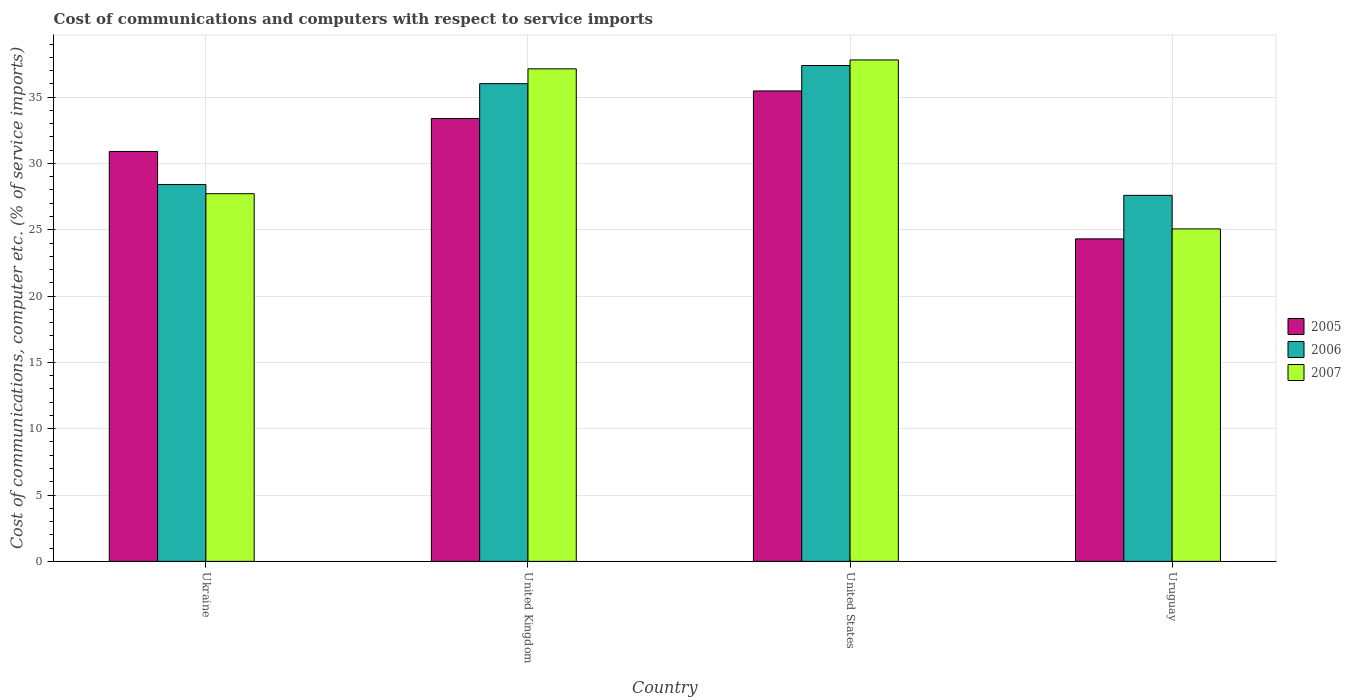How many groups of bars are there?
Ensure brevity in your answer.  4. Are the number of bars on each tick of the X-axis equal?
Provide a short and direct response. Yes. How many bars are there on the 1st tick from the right?
Provide a succinct answer. 3. What is the label of the 4th group of bars from the left?
Provide a succinct answer. Uruguay. In how many cases, is the number of bars for a given country not equal to the number of legend labels?
Offer a very short reply. 0. What is the cost of communications and computers in 2005 in Ukraine?
Give a very brief answer. 30.9. Across all countries, what is the maximum cost of communications and computers in 2006?
Provide a succinct answer. 37.38. Across all countries, what is the minimum cost of communications and computers in 2005?
Provide a short and direct response. 24.32. In which country was the cost of communications and computers in 2007 minimum?
Ensure brevity in your answer.  Uruguay. What is the total cost of communications and computers in 2006 in the graph?
Make the answer very short. 129.4. What is the difference between the cost of communications and computers in 2005 in Ukraine and that in United Kingdom?
Your answer should be compact. -2.49. What is the difference between the cost of communications and computers in 2006 in Ukraine and the cost of communications and computers in 2007 in Uruguay?
Offer a very short reply. 3.34. What is the average cost of communications and computers in 2007 per country?
Provide a short and direct response. 31.93. What is the difference between the cost of communications and computers of/in 2006 and cost of communications and computers of/in 2005 in Uruguay?
Provide a succinct answer. 3.28. In how many countries, is the cost of communications and computers in 2006 greater than 19 %?
Keep it short and to the point. 4. What is the ratio of the cost of communications and computers in 2007 in United Kingdom to that in Uruguay?
Offer a terse response. 1.48. Is the cost of communications and computers in 2005 in Ukraine less than that in Uruguay?
Make the answer very short. No. Is the difference between the cost of communications and computers in 2006 in Ukraine and Uruguay greater than the difference between the cost of communications and computers in 2005 in Ukraine and Uruguay?
Offer a very short reply. No. What is the difference between the highest and the second highest cost of communications and computers in 2006?
Your answer should be very brief. -7.61. What is the difference between the highest and the lowest cost of communications and computers in 2005?
Provide a succinct answer. 11.15. In how many countries, is the cost of communications and computers in 2006 greater than the average cost of communications and computers in 2006 taken over all countries?
Offer a very short reply. 2. What does the 3rd bar from the left in Uruguay represents?
Make the answer very short. 2007. Is it the case that in every country, the sum of the cost of communications and computers in 2005 and cost of communications and computers in 2006 is greater than the cost of communications and computers in 2007?
Ensure brevity in your answer.  Yes. Are all the bars in the graph horizontal?
Make the answer very short. No. What is the difference between two consecutive major ticks on the Y-axis?
Your answer should be very brief. 5. Where does the legend appear in the graph?
Provide a short and direct response. Center right. How many legend labels are there?
Give a very brief answer. 3. How are the legend labels stacked?
Provide a succinct answer. Vertical. What is the title of the graph?
Ensure brevity in your answer.  Cost of communications and computers with respect to service imports. What is the label or title of the Y-axis?
Give a very brief answer. Cost of communications, computer etc. (% of service imports). What is the Cost of communications, computer etc. (% of service imports) in 2005 in Ukraine?
Offer a very short reply. 30.9. What is the Cost of communications, computer etc. (% of service imports) in 2006 in Ukraine?
Your answer should be very brief. 28.41. What is the Cost of communications, computer etc. (% of service imports) in 2007 in Ukraine?
Ensure brevity in your answer.  27.72. What is the Cost of communications, computer etc. (% of service imports) of 2005 in United Kingdom?
Provide a short and direct response. 33.39. What is the Cost of communications, computer etc. (% of service imports) in 2006 in United Kingdom?
Make the answer very short. 36.02. What is the Cost of communications, computer etc. (% of service imports) of 2007 in United Kingdom?
Your response must be concise. 37.13. What is the Cost of communications, computer etc. (% of service imports) of 2005 in United States?
Offer a terse response. 35.47. What is the Cost of communications, computer etc. (% of service imports) in 2006 in United States?
Provide a succinct answer. 37.38. What is the Cost of communications, computer etc. (% of service imports) in 2007 in United States?
Keep it short and to the point. 37.8. What is the Cost of communications, computer etc. (% of service imports) of 2005 in Uruguay?
Provide a succinct answer. 24.32. What is the Cost of communications, computer etc. (% of service imports) in 2006 in Uruguay?
Your answer should be compact. 27.6. What is the Cost of communications, computer etc. (% of service imports) in 2007 in Uruguay?
Your response must be concise. 25.07. Across all countries, what is the maximum Cost of communications, computer etc. (% of service imports) of 2005?
Your response must be concise. 35.47. Across all countries, what is the maximum Cost of communications, computer etc. (% of service imports) of 2006?
Your answer should be very brief. 37.38. Across all countries, what is the maximum Cost of communications, computer etc. (% of service imports) in 2007?
Give a very brief answer. 37.8. Across all countries, what is the minimum Cost of communications, computer etc. (% of service imports) of 2005?
Your answer should be compact. 24.32. Across all countries, what is the minimum Cost of communications, computer etc. (% of service imports) of 2006?
Provide a succinct answer. 27.6. Across all countries, what is the minimum Cost of communications, computer etc. (% of service imports) of 2007?
Your answer should be very brief. 25.07. What is the total Cost of communications, computer etc. (% of service imports) in 2005 in the graph?
Your response must be concise. 124.08. What is the total Cost of communications, computer etc. (% of service imports) in 2006 in the graph?
Your answer should be compact. 129.4. What is the total Cost of communications, computer etc. (% of service imports) of 2007 in the graph?
Provide a succinct answer. 127.72. What is the difference between the Cost of communications, computer etc. (% of service imports) of 2005 in Ukraine and that in United Kingdom?
Ensure brevity in your answer.  -2.49. What is the difference between the Cost of communications, computer etc. (% of service imports) in 2006 in Ukraine and that in United Kingdom?
Your answer should be very brief. -7.61. What is the difference between the Cost of communications, computer etc. (% of service imports) of 2007 in Ukraine and that in United Kingdom?
Offer a very short reply. -9.41. What is the difference between the Cost of communications, computer etc. (% of service imports) of 2005 in Ukraine and that in United States?
Offer a very short reply. -4.56. What is the difference between the Cost of communications, computer etc. (% of service imports) in 2006 in Ukraine and that in United States?
Offer a very short reply. -8.97. What is the difference between the Cost of communications, computer etc. (% of service imports) of 2007 in Ukraine and that in United States?
Provide a short and direct response. -10.09. What is the difference between the Cost of communications, computer etc. (% of service imports) of 2005 in Ukraine and that in Uruguay?
Offer a terse response. 6.59. What is the difference between the Cost of communications, computer etc. (% of service imports) in 2006 in Ukraine and that in Uruguay?
Your response must be concise. 0.81. What is the difference between the Cost of communications, computer etc. (% of service imports) in 2007 in Ukraine and that in Uruguay?
Offer a terse response. 2.65. What is the difference between the Cost of communications, computer etc. (% of service imports) in 2005 in United Kingdom and that in United States?
Your answer should be compact. -2.08. What is the difference between the Cost of communications, computer etc. (% of service imports) in 2006 in United Kingdom and that in United States?
Offer a terse response. -1.37. What is the difference between the Cost of communications, computer etc. (% of service imports) of 2007 in United Kingdom and that in United States?
Your answer should be compact. -0.67. What is the difference between the Cost of communications, computer etc. (% of service imports) of 2005 in United Kingdom and that in Uruguay?
Provide a succinct answer. 9.08. What is the difference between the Cost of communications, computer etc. (% of service imports) of 2006 in United Kingdom and that in Uruguay?
Your answer should be very brief. 8.42. What is the difference between the Cost of communications, computer etc. (% of service imports) of 2007 in United Kingdom and that in Uruguay?
Offer a very short reply. 12.07. What is the difference between the Cost of communications, computer etc. (% of service imports) of 2005 in United States and that in Uruguay?
Keep it short and to the point. 11.15. What is the difference between the Cost of communications, computer etc. (% of service imports) in 2006 in United States and that in Uruguay?
Make the answer very short. 9.79. What is the difference between the Cost of communications, computer etc. (% of service imports) in 2007 in United States and that in Uruguay?
Your answer should be very brief. 12.74. What is the difference between the Cost of communications, computer etc. (% of service imports) in 2005 in Ukraine and the Cost of communications, computer etc. (% of service imports) in 2006 in United Kingdom?
Give a very brief answer. -5.11. What is the difference between the Cost of communications, computer etc. (% of service imports) of 2005 in Ukraine and the Cost of communications, computer etc. (% of service imports) of 2007 in United Kingdom?
Give a very brief answer. -6.23. What is the difference between the Cost of communications, computer etc. (% of service imports) of 2006 in Ukraine and the Cost of communications, computer etc. (% of service imports) of 2007 in United Kingdom?
Provide a succinct answer. -8.72. What is the difference between the Cost of communications, computer etc. (% of service imports) in 2005 in Ukraine and the Cost of communications, computer etc. (% of service imports) in 2006 in United States?
Your answer should be very brief. -6.48. What is the difference between the Cost of communications, computer etc. (% of service imports) of 2005 in Ukraine and the Cost of communications, computer etc. (% of service imports) of 2007 in United States?
Keep it short and to the point. -6.9. What is the difference between the Cost of communications, computer etc. (% of service imports) in 2006 in Ukraine and the Cost of communications, computer etc. (% of service imports) in 2007 in United States?
Provide a succinct answer. -9.4. What is the difference between the Cost of communications, computer etc. (% of service imports) in 2005 in Ukraine and the Cost of communications, computer etc. (% of service imports) in 2006 in Uruguay?
Make the answer very short. 3.31. What is the difference between the Cost of communications, computer etc. (% of service imports) in 2005 in Ukraine and the Cost of communications, computer etc. (% of service imports) in 2007 in Uruguay?
Offer a very short reply. 5.84. What is the difference between the Cost of communications, computer etc. (% of service imports) of 2006 in Ukraine and the Cost of communications, computer etc. (% of service imports) of 2007 in Uruguay?
Your answer should be compact. 3.34. What is the difference between the Cost of communications, computer etc. (% of service imports) of 2005 in United Kingdom and the Cost of communications, computer etc. (% of service imports) of 2006 in United States?
Your response must be concise. -3.99. What is the difference between the Cost of communications, computer etc. (% of service imports) of 2005 in United Kingdom and the Cost of communications, computer etc. (% of service imports) of 2007 in United States?
Make the answer very short. -4.41. What is the difference between the Cost of communications, computer etc. (% of service imports) of 2006 in United Kingdom and the Cost of communications, computer etc. (% of service imports) of 2007 in United States?
Keep it short and to the point. -1.79. What is the difference between the Cost of communications, computer etc. (% of service imports) of 2005 in United Kingdom and the Cost of communications, computer etc. (% of service imports) of 2006 in Uruguay?
Keep it short and to the point. 5.79. What is the difference between the Cost of communications, computer etc. (% of service imports) in 2005 in United Kingdom and the Cost of communications, computer etc. (% of service imports) in 2007 in Uruguay?
Keep it short and to the point. 8.32. What is the difference between the Cost of communications, computer etc. (% of service imports) of 2006 in United Kingdom and the Cost of communications, computer etc. (% of service imports) of 2007 in Uruguay?
Make the answer very short. 10.95. What is the difference between the Cost of communications, computer etc. (% of service imports) in 2005 in United States and the Cost of communications, computer etc. (% of service imports) in 2006 in Uruguay?
Keep it short and to the point. 7.87. What is the difference between the Cost of communications, computer etc. (% of service imports) of 2005 in United States and the Cost of communications, computer etc. (% of service imports) of 2007 in Uruguay?
Your response must be concise. 10.4. What is the difference between the Cost of communications, computer etc. (% of service imports) in 2006 in United States and the Cost of communications, computer etc. (% of service imports) in 2007 in Uruguay?
Your answer should be very brief. 12.32. What is the average Cost of communications, computer etc. (% of service imports) of 2005 per country?
Your answer should be very brief. 31.02. What is the average Cost of communications, computer etc. (% of service imports) of 2006 per country?
Provide a short and direct response. 32.35. What is the average Cost of communications, computer etc. (% of service imports) in 2007 per country?
Keep it short and to the point. 31.93. What is the difference between the Cost of communications, computer etc. (% of service imports) of 2005 and Cost of communications, computer etc. (% of service imports) of 2006 in Ukraine?
Offer a terse response. 2.5. What is the difference between the Cost of communications, computer etc. (% of service imports) in 2005 and Cost of communications, computer etc. (% of service imports) in 2007 in Ukraine?
Offer a terse response. 3.19. What is the difference between the Cost of communications, computer etc. (% of service imports) of 2006 and Cost of communications, computer etc. (% of service imports) of 2007 in Ukraine?
Your answer should be compact. 0.69. What is the difference between the Cost of communications, computer etc. (% of service imports) in 2005 and Cost of communications, computer etc. (% of service imports) in 2006 in United Kingdom?
Provide a short and direct response. -2.63. What is the difference between the Cost of communications, computer etc. (% of service imports) in 2005 and Cost of communications, computer etc. (% of service imports) in 2007 in United Kingdom?
Provide a short and direct response. -3.74. What is the difference between the Cost of communications, computer etc. (% of service imports) in 2006 and Cost of communications, computer etc. (% of service imports) in 2007 in United Kingdom?
Make the answer very short. -1.12. What is the difference between the Cost of communications, computer etc. (% of service imports) of 2005 and Cost of communications, computer etc. (% of service imports) of 2006 in United States?
Give a very brief answer. -1.91. What is the difference between the Cost of communications, computer etc. (% of service imports) of 2005 and Cost of communications, computer etc. (% of service imports) of 2007 in United States?
Your response must be concise. -2.34. What is the difference between the Cost of communications, computer etc. (% of service imports) in 2006 and Cost of communications, computer etc. (% of service imports) in 2007 in United States?
Ensure brevity in your answer.  -0.42. What is the difference between the Cost of communications, computer etc. (% of service imports) of 2005 and Cost of communications, computer etc. (% of service imports) of 2006 in Uruguay?
Give a very brief answer. -3.28. What is the difference between the Cost of communications, computer etc. (% of service imports) in 2005 and Cost of communications, computer etc. (% of service imports) in 2007 in Uruguay?
Offer a terse response. -0.75. What is the difference between the Cost of communications, computer etc. (% of service imports) in 2006 and Cost of communications, computer etc. (% of service imports) in 2007 in Uruguay?
Offer a very short reply. 2.53. What is the ratio of the Cost of communications, computer etc. (% of service imports) of 2005 in Ukraine to that in United Kingdom?
Provide a succinct answer. 0.93. What is the ratio of the Cost of communications, computer etc. (% of service imports) in 2006 in Ukraine to that in United Kingdom?
Ensure brevity in your answer.  0.79. What is the ratio of the Cost of communications, computer etc. (% of service imports) of 2007 in Ukraine to that in United Kingdom?
Your response must be concise. 0.75. What is the ratio of the Cost of communications, computer etc. (% of service imports) of 2005 in Ukraine to that in United States?
Keep it short and to the point. 0.87. What is the ratio of the Cost of communications, computer etc. (% of service imports) of 2006 in Ukraine to that in United States?
Provide a short and direct response. 0.76. What is the ratio of the Cost of communications, computer etc. (% of service imports) in 2007 in Ukraine to that in United States?
Offer a terse response. 0.73. What is the ratio of the Cost of communications, computer etc. (% of service imports) of 2005 in Ukraine to that in Uruguay?
Your answer should be very brief. 1.27. What is the ratio of the Cost of communications, computer etc. (% of service imports) of 2006 in Ukraine to that in Uruguay?
Ensure brevity in your answer.  1.03. What is the ratio of the Cost of communications, computer etc. (% of service imports) of 2007 in Ukraine to that in Uruguay?
Offer a very short reply. 1.11. What is the ratio of the Cost of communications, computer etc. (% of service imports) in 2005 in United Kingdom to that in United States?
Your answer should be very brief. 0.94. What is the ratio of the Cost of communications, computer etc. (% of service imports) of 2006 in United Kingdom to that in United States?
Your answer should be compact. 0.96. What is the ratio of the Cost of communications, computer etc. (% of service imports) of 2007 in United Kingdom to that in United States?
Your answer should be very brief. 0.98. What is the ratio of the Cost of communications, computer etc. (% of service imports) in 2005 in United Kingdom to that in Uruguay?
Ensure brevity in your answer.  1.37. What is the ratio of the Cost of communications, computer etc. (% of service imports) in 2006 in United Kingdom to that in Uruguay?
Provide a short and direct response. 1.31. What is the ratio of the Cost of communications, computer etc. (% of service imports) of 2007 in United Kingdom to that in Uruguay?
Offer a very short reply. 1.48. What is the ratio of the Cost of communications, computer etc. (% of service imports) in 2005 in United States to that in Uruguay?
Give a very brief answer. 1.46. What is the ratio of the Cost of communications, computer etc. (% of service imports) of 2006 in United States to that in Uruguay?
Keep it short and to the point. 1.35. What is the ratio of the Cost of communications, computer etc. (% of service imports) in 2007 in United States to that in Uruguay?
Ensure brevity in your answer.  1.51. What is the difference between the highest and the second highest Cost of communications, computer etc. (% of service imports) of 2005?
Your answer should be compact. 2.08. What is the difference between the highest and the second highest Cost of communications, computer etc. (% of service imports) in 2006?
Offer a very short reply. 1.37. What is the difference between the highest and the second highest Cost of communications, computer etc. (% of service imports) of 2007?
Your answer should be compact. 0.67. What is the difference between the highest and the lowest Cost of communications, computer etc. (% of service imports) of 2005?
Your answer should be compact. 11.15. What is the difference between the highest and the lowest Cost of communications, computer etc. (% of service imports) in 2006?
Provide a succinct answer. 9.79. What is the difference between the highest and the lowest Cost of communications, computer etc. (% of service imports) of 2007?
Give a very brief answer. 12.74. 